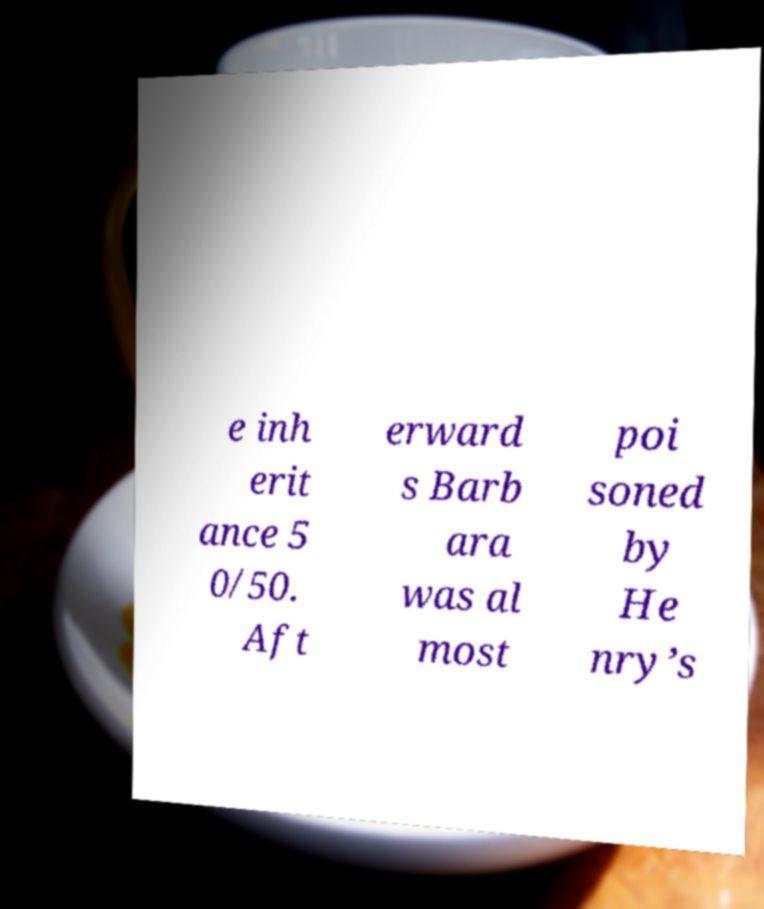Can you accurately transcribe the text from the provided image for me? e inh erit ance 5 0/50. Aft erward s Barb ara was al most poi soned by He nry’s 